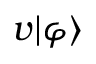Convert formula to latex. <formula><loc_0><loc_0><loc_500><loc_500>v | \varphi \rangle</formula> 